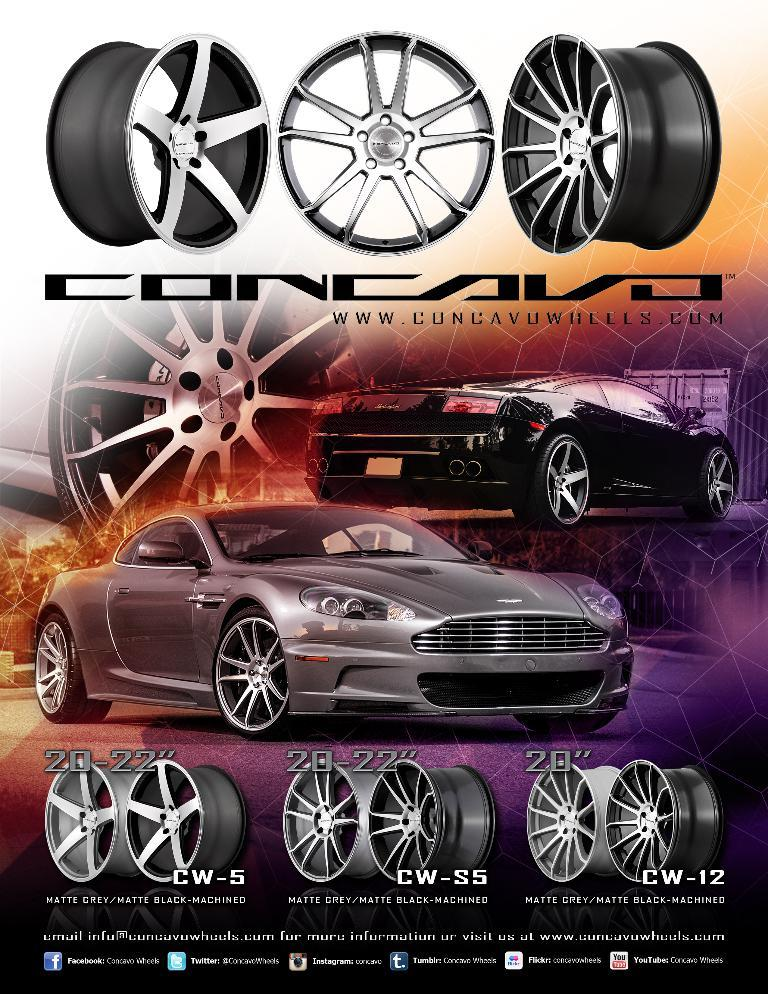What is the main subject of the poster in the image? The main subject of the poster is a grey and black car. What other elements are present on the poster? The poster contains an image of car wheels and a quotation at the bottom. Is there any poison visible on the poster? No, there is no poison present on the poster. Can you see any cobwebs in the image? No, there are no cobwebs visible in the image. 